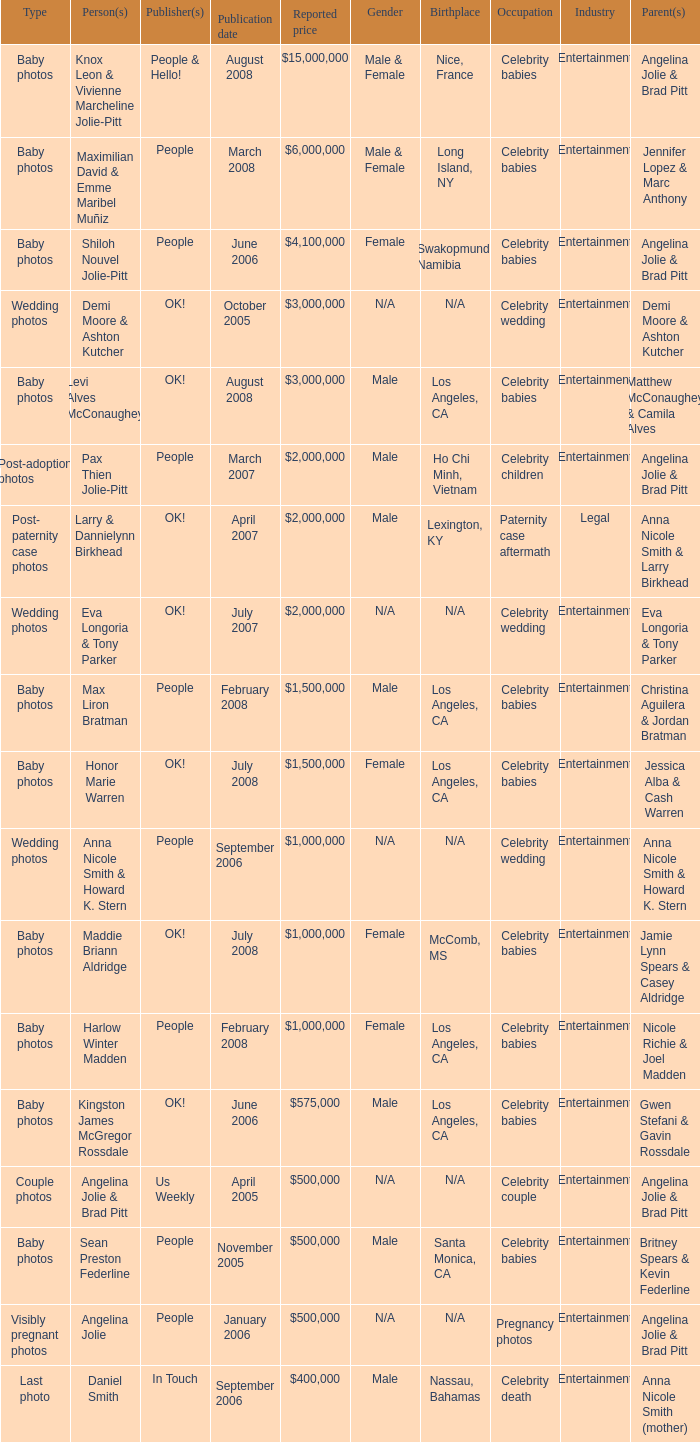What type of photos of Angelina Jolie cost $500,000? Visibly pregnant photos. 